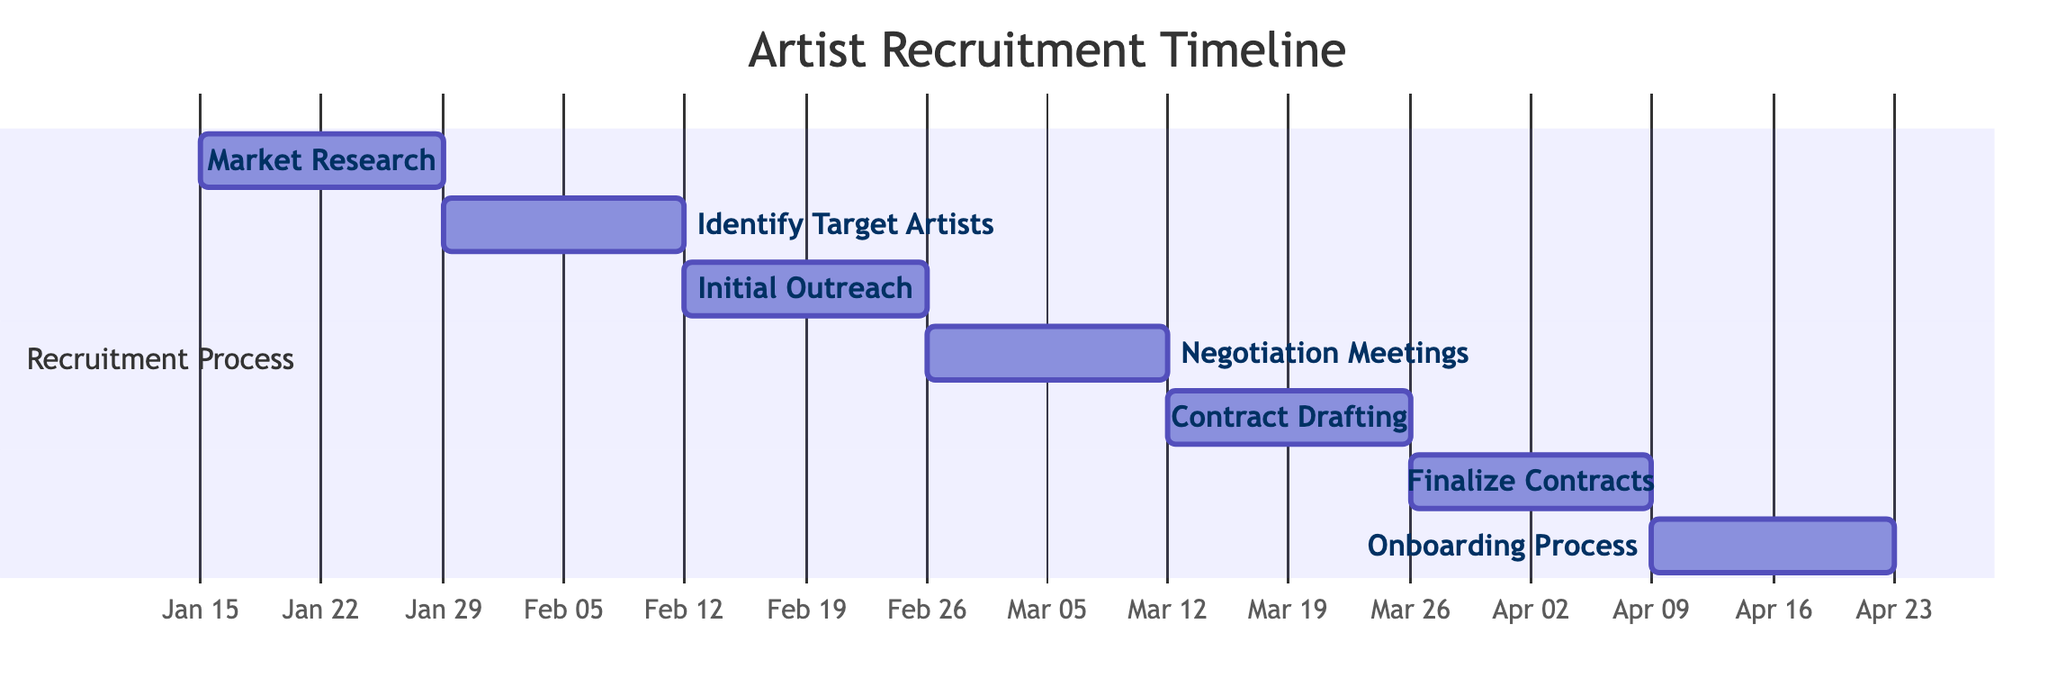What is the total number of tasks in the recruitment process? The diagram lists seven tasks in the recruitment process, which are Market Research, Identify Target Artists, Initial Outreach, Negotiation Meetings, Contract Drafting, Finalize Contracts, and Onboarding Process. Counting these tasks gives a total of seven.
Answer: 7 Which task starts immediately after the Initial Outreach? According to the visual information, Initial Outreach is followed by Negotiation Meetings. Therefore, the task that starts immediately after is Negotiation Meetings.
Answer: Negotiation Meetings What is the duration of the Contract Drafting task? The diagram specifies that the Contract Drafting task has a duration of 2 weeks. This duration is visually indicated next to the task in the timeline.
Answer: 2 weeks What are the start and end dates of the Onboarding Process? The Onboarding Process starts on April 10, 2023, and ends on April 23, 2023, as clearly shown in the time span within the Gantt chart for that specific task.
Answer: April 10, 2023 - April 23, 2023 Which task occurs in the month of March? From the timeline, we can see that the tasks that occur in March are Negotiation Meetings, Contract Drafting, and Finalize Contracts. These tasks are all scheduled between March 1 and March 31, 2023.
Answer: Negotiation Meetings, Contract Drafting, Finalize Contracts How many weeks does the recruitment process take in total? By adding up the duration of each task (2 weeks each for seven tasks), the total duration is 14 weeks. The cumulative effort depicted in the Gantt chart supports this timeframe.
Answer: 14 weeks What task occurs directly before Finalize Contracts? The Gantt chart indicates that the task right before Finalize Contracts is Contract Drafting. This can be seen by observing the ordering of tasks in the timeline.
Answer: Contract Drafting Which task has the latest end date? The Onboarding Process task has the latest end date of April 23, 2023, which is confirmed by inspecting the end dates of all tasks in the timeline.
Answer: Onboarding Process 